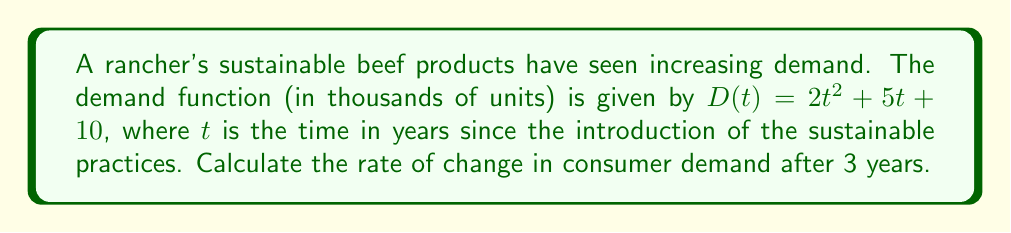Give your solution to this math problem. To find the rate of change in consumer demand, we need to calculate the derivative of the demand function and evaluate it at $t = 3$.

1. The demand function is $D(t) = 2t^2 + 5t + 10$

2. To find the rate of change, we calculate the derivative $D'(t)$:
   $$D'(t) = \frac{d}{dt}(2t^2 + 5t + 10)$$
   $$D'(t) = 4t + 5$$

3. Now, we evaluate $D'(t)$ at $t = 3$:
   $$D'(3) = 4(3) + 5$$
   $$D'(3) = 12 + 5 = 17$$

4. The units of the result are thousands of units per year, as the original function was in thousands of units and $t$ is in years.

Therefore, the rate of change in consumer demand after 3 years is 17,000 units per year.
Answer: 17,000 units/year 